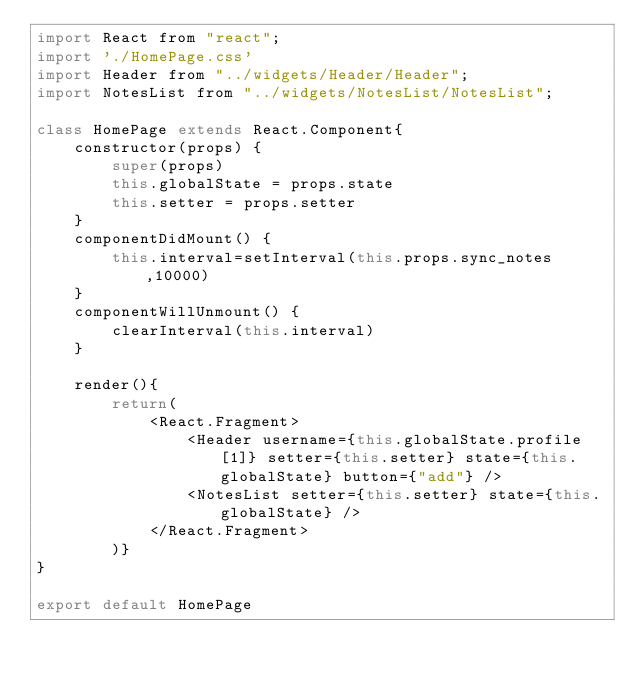<code> <loc_0><loc_0><loc_500><loc_500><_JavaScript_>import React from "react";
import './HomePage.css'
import Header from "../widgets/Header/Header";
import NotesList from "../widgets/NotesList/NotesList";

class HomePage extends React.Component{
    constructor(props) {
        super(props)
        this.globalState = props.state
        this.setter = props.setter
    }
    componentDidMount() {
        this.interval=setInterval(this.props.sync_notes,10000)
    }
    componentWillUnmount() {
        clearInterval(this.interval)
    }

    render(){
        return(
            <React.Fragment>
                <Header username={this.globalState.profile[1]} setter={this.setter} state={this.globalState} button={"add"} />
                <NotesList setter={this.setter} state={this.globalState} />
            </React.Fragment>
        )}
}

export default HomePage
</code> 